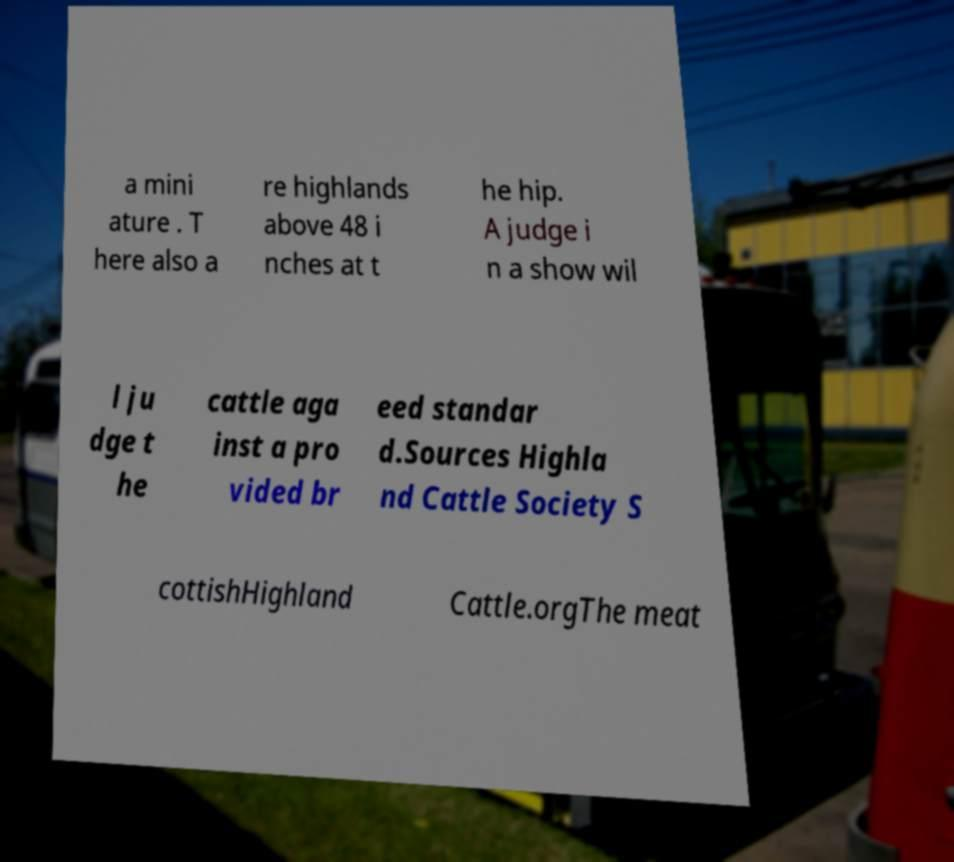Please read and relay the text visible in this image. What does it say? a mini ature . T here also a re highlands above 48 i nches at t he hip. A judge i n a show wil l ju dge t he cattle aga inst a pro vided br eed standar d.Sources Highla nd Cattle Society S cottishHighland Cattle.orgThe meat 